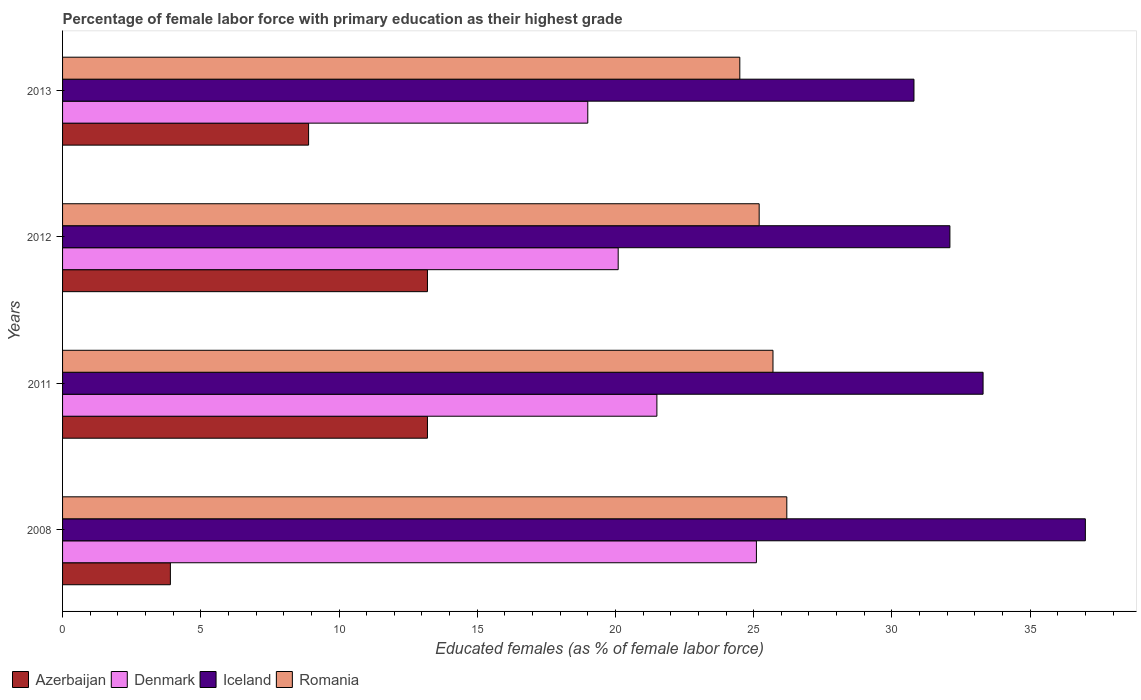How many different coloured bars are there?
Offer a terse response. 4. Are the number of bars on each tick of the Y-axis equal?
Offer a very short reply. Yes. How many bars are there on the 3rd tick from the top?
Make the answer very short. 4. What is the percentage of female labor force with primary education in Azerbaijan in 2012?
Keep it short and to the point. 13.2. Across all years, what is the maximum percentage of female labor force with primary education in Denmark?
Provide a succinct answer. 25.1. In which year was the percentage of female labor force with primary education in Romania maximum?
Your answer should be compact. 2008. What is the total percentage of female labor force with primary education in Iceland in the graph?
Give a very brief answer. 133.2. What is the difference between the percentage of female labor force with primary education in Denmark in 2008 and that in 2012?
Keep it short and to the point. 5. What is the difference between the percentage of female labor force with primary education in Denmark in 2008 and the percentage of female labor force with primary education in Romania in 2012?
Provide a short and direct response. -0.1. What is the average percentage of female labor force with primary education in Iceland per year?
Ensure brevity in your answer.  33.3. In the year 2011, what is the difference between the percentage of female labor force with primary education in Iceland and percentage of female labor force with primary education in Romania?
Give a very brief answer. 7.6. What is the ratio of the percentage of female labor force with primary education in Azerbaijan in 2008 to that in 2013?
Give a very brief answer. 0.44. Is the percentage of female labor force with primary education in Azerbaijan in 2011 less than that in 2012?
Your response must be concise. No. Is the difference between the percentage of female labor force with primary education in Iceland in 2008 and 2011 greater than the difference between the percentage of female labor force with primary education in Romania in 2008 and 2011?
Give a very brief answer. Yes. What is the difference between the highest and the second highest percentage of female labor force with primary education in Denmark?
Your answer should be very brief. 3.6. What is the difference between the highest and the lowest percentage of female labor force with primary education in Iceland?
Your answer should be very brief. 6.2. What does the 3rd bar from the top in 2013 represents?
Offer a very short reply. Denmark. What does the 4th bar from the bottom in 2011 represents?
Give a very brief answer. Romania. Are all the bars in the graph horizontal?
Your response must be concise. Yes. How many years are there in the graph?
Make the answer very short. 4. What is the difference between two consecutive major ticks on the X-axis?
Your answer should be very brief. 5. Are the values on the major ticks of X-axis written in scientific E-notation?
Your response must be concise. No. Does the graph contain grids?
Offer a very short reply. No. Where does the legend appear in the graph?
Keep it short and to the point. Bottom left. How many legend labels are there?
Keep it short and to the point. 4. How are the legend labels stacked?
Provide a succinct answer. Horizontal. What is the title of the graph?
Your answer should be compact. Percentage of female labor force with primary education as their highest grade. What is the label or title of the X-axis?
Ensure brevity in your answer.  Educated females (as % of female labor force). What is the Educated females (as % of female labor force) of Azerbaijan in 2008?
Your answer should be compact. 3.9. What is the Educated females (as % of female labor force) in Denmark in 2008?
Make the answer very short. 25.1. What is the Educated females (as % of female labor force) in Iceland in 2008?
Your answer should be very brief. 37. What is the Educated females (as % of female labor force) of Romania in 2008?
Provide a short and direct response. 26.2. What is the Educated females (as % of female labor force) of Azerbaijan in 2011?
Offer a very short reply. 13.2. What is the Educated females (as % of female labor force) in Iceland in 2011?
Your answer should be very brief. 33.3. What is the Educated females (as % of female labor force) of Romania in 2011?
Your response must be concise. 25.7. What is the Educated females (as % of female labor force) of Azerbaijan in 2012?
Offer a terse response. 13.2. What is the Educated females (as % of female labor force) in Denmark in 2012?
Your response must be concise. 20.1. What is the Educated females (as % of female labor force) in Iceland in 2012?
Offer a terse response. 32.1. What is the Educated females (as % of female labor force) in Romania in 2012?
Your answer should be very brief. 25.2. What is the Educated females (as % of female labor force) in Azerbaijan in 2013?
Make the answer very short. 8.9. What is the Educated females (as % of female labor force) of Iceland in 2013?
Offer a very short reply. 30.8. Across all years, what is the maximum Educated females (as % of female labor force) in Azerbaijan?
Keep it short and to the point. 13.2. Across all years, what is the maximum Educated females (as % of female labor force) in Denmark?
Your answer should be very brief. 25.1. Across all years, what is the maximum Educated females (as % of female labor force) of Iceland?
Ensure brevity in your answer.  37. Across all years, what is the maximum Educated females (as % of female labor force) of Romania?
Offer a very short reply. 26.2. Across all years, what is the minimum Educated females (as % of female labor force) of Azerbaijan?
Keep it short and to the point. 3.9. Across all years, what is the minimum Educated females (as % of female labor force) in Iceland?
Provide a short and direct response. 30.8. What is the total Educated females (as % of female labor force) in Azerbaijan in the graph?
Provide a short and direct response. 39.2. What is the total Educated females (as % of female labor force) in Denmark in the graph?
Keep it short and to the point. 85.7. What is the total Educated females (as % of female labor force) of Iceland in the graph?
Give a very brief answer. 133.2. What is the total Educated females (as % of female labor force) of Romania in the graph?
Ensure brevity in your answer.  101.6. What is the difference between the Educated females (as % of female labor force) of Denmark in 2008 and that in 2011?
Make the answer very short. 3.6. What is the difference between the Educated females (as % of female labor force) in Azerbaijan in 2008 and that in 2012?
Make the answer very short. -9.3. What is the difference between the Educated females (as % of female labor force) in Iceland in 2008 and that in 2012?
Your response must be concise. 4.9. What is the difference between the Educated females (as % of female labor force) of Romania in 2008 and that in 2012?
Keep it short and to the point. 1. What is the difference between the Educated females (as % of female labor force) in Azerbaijan in 2008 and that in 2013?
Provide a succinct answer. -5. What is the difference between the Educated females (as % of female labor force) of Denmark in 2008 and that in 2013?
Your answer should be compact. 6.1. What is the difference between the Educated females (as % of female labor force) of Iceland in 2008 and that in 2013?
Your response must be concise. 6.2. What is the difference between the Educated females (as % of female labor force) in Romania in 2008 and that in 2013?
Offer a very short reply. 1.7. What is the difference between the Educated females (as % of female labor force) in Azerbaijan in 2011 and that in 2012?
Offer a very short reply. 0. What is the difference between the Educated females (as % of female labor force) in Denmark in 2011 and that in 2012?
Your response must be concise. 1.4. What is the difference between the Educated females (as % of female labor force) of Denmark in 2011 and that in 2013?
Offer a terse response. 2.5. What is the difference between the Educated females (as % of female labor force) in Azerbaijan in 2012 and that in 2013?
Keep it short and to the point. 4.3. What is the difference between the Educated females (as % of female labor force) in Iceland in 2012 and that in 2013?
Offer a very short reply. 1.3. What is the difference between the Educated females (as % of female labor force) in Romania in 2012 and that in 2013?
Your response must be concise. 0.7. What is the difference between the Educated females (as % of female labor force) of Azerbaijan in 2008 and the Educated females (as % of female labor force) of Denmark in 2011?
Provide a short and direct response. -17.6. What is the difference between the Educated females (as % of female labor force) of Azerbaijan in 2008 and the Educated females (as % of female labor force) of Iceland in 2011?
Keep it short and to the point. -29.4. What is the difference between the Educated females (as % of female labor force) of Azerbaijan in 2008 and the Educated females (as % of female labor force) of Romania in 2011?
Give a very brief answer. -21.8. What is the difference between the Educated females (as % of female labor force) in Denmark in 2008 and the Educated females (as % of female labor force) in Iceland in 2011?
Provide a short and direct response. -8.2. What is the difference between the Educated females (as % of female labor force) in Denmark in 2008 and the Educated females (as % of female labor force) in Romania in 2011?
Give a very brief answer. -0.6. What is the difference between the Educated females (as % of female labor force) of Iceland in 2008 and the Educated females (as % of female labor force) of Romania in 2011?
Your response must be concise. 11.3. What is the difference between the Educated females (as % of female labor force) of Azerbaijan in 2008 and the Educated females (as % of female labor force) of Denmark in 2012?
Provide a short and direct response. -16.2. What is the difference between the Educated females (as % of female labor force) of Azerbaijan in 2008 and the Educated females (as % of female labor force) of Iceland in 2012?
Provide a succinct answer. -28.2. What is the difference between the Educated females (as % of female labor force) in Azerbaijan in 2008 and the Educated females (as % of female labor force) in Romania in 2012?
Keep it short and to the point. -21.3. What is the difference between the Educated females (as % of female labor force) of Denmark in 2008 and the Educated females (as % of female labor force) of Iceland in 2012?
Offer a terse response. -7. What is the difference between the Educated females (as % of female labor force) in Denmark in 2008 and the Educated females (as % of female labor force) in Romania in 2012?
Your answer should be compact. -0.1. What is the difference between the Educated females (as % of female labor force) of Iceland in 2008 and the Educated females (as % of female labor force) of Romania in 2012?
Make the answer very short. 11.8. What is the difference between the Educated females (as % of female labor force) in Azerbaijan in 2008 and the Educated females (as % of female labor force) in Denmark in 2013?
Offer a terse response. -15.1. What is the difference between the Educated females (as % of female labor force) of Azerbaijan in 2008 and the Educated females (as % of female labor force) of Iceland in 2013?
Give a very brief answer. -26.9. What is the difference between the Educated females (as % of female labor force) of Azerbaijan in 2008 and the Educated females (as % of female labor force) of Romania in 2013?
Offer a very short reply. -20.6. What is the difference between the Educated females (as % of female labor force) of Denmark in 2008 and the Educated females (as % of female labor force) of Iceland in 2013?
Give a very brief answer. -5.7. What is the difference between the Educated females (as % of female labor force) in Denmark in 2008 and the Educated females (as % of female labor force) in Romania in 2013?
Ensure brevity in your answer.  0.6. What is the difference between the Educated females (as % of female labor force) of Iceland in 2008 and the Educated females (as % of female labor force) of Romania in 2013?
Keep it short and to the point. 12.5. What is the difference between the Educated females (as % of female labor force) of Azerbaijan in 2011 and the Educated females (as % of female labor force) of Denmark in 2012?
Your response must be concise. -6.9. What is the difference between the Educated females (as % of female labor force) in Azerbaijan in 2011 and the Educated females (as % of female labor force) in Iceland in 2012?
Your response must be concise. -18.9. What is the difference between the Educated females (as % of female labor force) in Azerbaijan in 2011 and the Educated females (as % of female labor force) in Romania in 2012?
Make the answer very short. -12. What is the difference between the Educated females (as % of female labor force) of Azerbaijan in 2011 and the Educated females (as % of female labor force) of Denmark in 2013?
Offer a terse response. -5.8. What is the difference between the Educated females (as % of female labor force) in Azerbaijan in 2011 and the Educated females (as % of female labor force) in Iceland in 2013?
Your answer should be very brief. -17.6. What is the difference between the Educated females (as % of female labor force) of Azerbaijan in 2011 and the Educated females (as % of female labor force) of Romania in 2013?
Your response must be concise. -11.3. What is the difference between the Educated females (as % of female labor force) in Iceland in 2011 and the Educated females (as % of female labor force) in Romania in 2013?
Keep it short and to the point. 8.8. What is the difference between the Educated females (as % of female labor force) in Azerbaijan in 2012 and the Educated females (as % of female labor force) in Denmark in 2013?
Provide a short and direct response. -5.8. What is the difference between the Educated females (as % of female labor force) in Azerbaijan in 2012 and the Educated females (as % of female labor force) in Iceland in 2013?
Give a very brief answer. -17.6. What is the difference between the Educated females (as % of female labor force) of Azerbaijan in 2012 and the Educated females (as % of female labor force) of Romania in 2013?
Give a very brief answer. -11.3. What is the difference between the Educated females (as % of female labor force) of Denmark in 2012 and the Educated females (as % of female labor force) of Iceland in 2013?
Your answer should be very brief. -10.7. What is the difference between the Educated females (as % of female labor force) in Denmark in 2012 and the Educated females (as % of female labor force) in Romania in 2013?
Ensure brevity in your answer.  -4.4. What is the average Educated females (as % of female labor force) of Denmark per year?
Provide a short and direct response. 21.43. What is the average Educated females (as % of female labor force) in Iceland per year?
Your response must be concise. 33.3. What is the average Educated females (as % of female labor force) in Romania per year?
Offer a very short reply. 25.4. In the year 2008, what is the difference between the Educated females (as % of female labor force) in Azerbaijan and Educated females (as % of female labor force) in Denmark?
Provide a succinct answer. -21.2. In the year 2008, what is the difference between the Educated females (as % of female labor force) in Azerbaijan and Educated females (as % of female labor force) in Iceland?
Provide a succinct answer. -33.1. In the year 2008, what is the difference between the Educated females (as % of female labor force) of Azerbaijan and Educated females (as % of female labor force) of Romania?
Your response must be concise. -22.3. In the year 2008, what is the difference between the Educated females (as % of female labor force) in Denmark and Educated females (as % of female labor force) in Iceland?
Offer a terse response. -11.9. In the year 2008, what is the difference between the Educated females (as % of female labor force) of Denmark and Educated females (as % of female labor force) of Romania?
Give a very brief answer. -1.1. In the year 2011, what is the difference between the Educated females (as % of female labor force) in Azerbaijan and Educated females (as % of female labor force) in Denmark?
Keep it short and to the point. -8.3. In the year 2011, what is the difference between the Educated females (as % of female labor force) in Azerbaijan and Educated females (as % of female labor force) in Iceland?
Your answer should be compact. -20.1. In the year 2011, what is the difference between the Educated females (as % of female labor force) of Azerbaijan and Educated females (as % of female labor force) of Romania?
Offer a terse response. -12.5. In the year 2011, what is the difference between the Educated females (as % of female labor force) in Denmark and Educated females (as % of female labor force) in Romania?
Provide a succinct answer. -4.2. In the year 2011, what is the difference between the Educated females (as % of female labor force) of Iceland and Educated females (as % of female labor force) of Romania?
Provide a short and direct response. 7.6. In the year 2012, what is the difference between the Educated females (as % of female labor force) of Azerbaijan and Educated females (as % of female labor force) of Iceland?
Offer a terse response. -18.9. In the year 2012, what is the difference between the Educated females (as % of female labor force) of Azerbaijan and Educated females (as % of female labor force) of Romania?
Keep it short and to the point. -12. In the year 2012, what is the difference between the Educated females (as % of female labor force) in Denmark and Educated females (as % of female labor force) in Iceland?
Provide a short and direct response. -12. In the year 2012, what is the difference between the Educated females (as % of female labor force) in Iceland and Educated females (as % of female labor force) in Romania?
Provide a short and direct response. 6.9. In the year 2013, what is the difference between the Educated females (as % of female labor force) in Azerbaijan and Educated females (as % of female labor force) in Denmark?
Provide a short and direct response. -10.1. In the year 2013, what is the difference between the Educated females (as % of female labor force) in Azerbaijan and Educated females (as % of female labor force) in Iceland?
Provide a short and direct response. -21.9. In the year 2013, what is the difference between the Educated females (as % of female labor force) in Azerbaijan and Educated females (as % of female labor force) in Romania?
Give a very brief answer. -15.6. In the year 2013, what is the difference between the Educated females (as % of female labor force) in Denmark and Educated females (as % of female labor force) in Iceland?
Provide a succinct answer. -11.8. In the year 2013, what is the difference between the Educated females (as % of female labor force) of Iceland and Educated females (as % of female labor force) of Romania?
Provide a succinct answer. 6.3. What is the ratio of the Educated females (as % of female labor force) of Azerbaijan in 2008 to that in 2011?
Your answer should be compact. 0.3. What is the ratio of the Educated females (as % of female labor force) of Denmark in 2008 to that in 2011?
Make the answer very short. 1.17. What is the ratio of the Educated females (as % of female labor force) in Iceland in 2008 to that in 2011?
Give a very brief answer. 1.11. What is the ratio of the Educated females (as % of female labor force) of Romania in 2008 to that in 2011?
Offer a very short reply. 1.02. What is the ratio of the Educated females (as % of female labor force) in Azerbaijan in 2008 to that in 2012?
Provide a short and direct response. 0.3. What is the ratio of the Educated females (as % of female labor force) in Denmark in 2008 to that in 2012?
Provide a short and direct response. 1.25. What is the ratio of the Educated females (as % of female labor force) of Iceland in 2008 to that in 2012?
Keep it short and to the point. 1.15. What is the ratio of the Educated females (as % of female labor force) of Romania in 2008 to that in 2012?
Ensure brevity in your answer.  1.04. What is the ratio of the Educated females (as % of female labor force) in Azerbaijan in 2008 to that in 2013?
Ensure brevity in your answer.  0.44. What is the ratio of the Educated females (as % of female labor force) of Denmark in 2008 to that in 2013?
Your response must be concise. 1.32. What is the ratio of the Educated females (as % of female labor force) in Iceland in 2008 to that in 2013?
Your answer should be compact. 1.2. What is the ratio of the Educated females (as % of female labor force) of Romania in 2008 to that in 2013?
Your response must be concise. 1.07. What is the ratio of the Educated females (as % of female labor force) of Denmark in 2011 to that in 2012?
Your answer should be compact. 1.07. What is the ratio of the Educated females (as % of female labor force) in Iceland in 2011 to that in 2012?
Your answer should be very brief. 1.04. What is the ratio of the Educated females (as % of female labor force) in Romania in 2011 to that in 2012?
Give a very brief answer. 1.02. What is the ratio of the Educated females (as % of female labor force) of Azerbaijan in 2011 to that in 2013?
Provide a succinct answer. 1.48. What is the ratio of the Educated females (as % of female labor force) in Denmark in 2011 to that in 2013?
Offer a very short reply. 1.13. What is the ratio of the Educated females (as % of female labor force) in Iceland in 2011 to that in 2013?
Provide a short and direct response. 1.08. What is the ratio of the Educated females (as % of female labor force) of Romania in 2011 to that in 2013?
Provide a succinct answer. 1.05. What is the ratio of the Educated females (as % of female labor force) of Azerbaijan in 2012 to that in 2013?
Give a very brief answer. 1.48. What is the ratio of the Educated females (as % of female labor force) of Denmark in 2012 to that in 2013?
Provide a short and direct response. 1.06. What is the ratio of the Educated females (as % of female labor force) in Iceland in 2012 to that in 2013?
Your answer should be compact. 1.04. What is the ratio of the Educated females (as % of female labor force) in Romania in 2012 to that in 2013?
Your response must be concise. 1.03. What is the difference between the highest and the second highest Educated females (as % of female labor force) in Azerbaijan?
Your response must be concise. 0. What is the difference between the highest and the lowest Educated females (as % of female labor force) in Romania?
Ensure brevity in your answer.  1.7. 